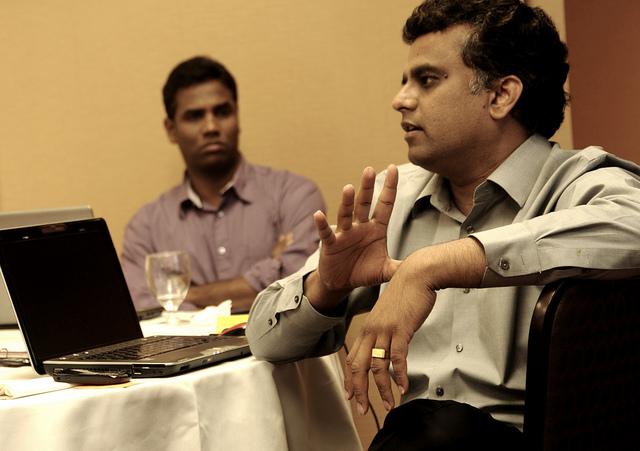Is the glass empty or full?
Write a very short answer. Empty. Is the man wearing a badge around his neck?
Give a very brief answer. No. Where is the man staring at?
Concise answer only. Computer. How many men have white hair?
Answer briefly. 0. What ethnicity are the people in the picture?
Write a very short answer. Indian. How many maps are visible on the walls?
Answer briefly. 0. Why is the other man mad?
Concise answer only. He doesn't like what other man is saying. How many people are using laptops?
Answer briefly. 2. Is this man married?
Concise answer only. Yes. 